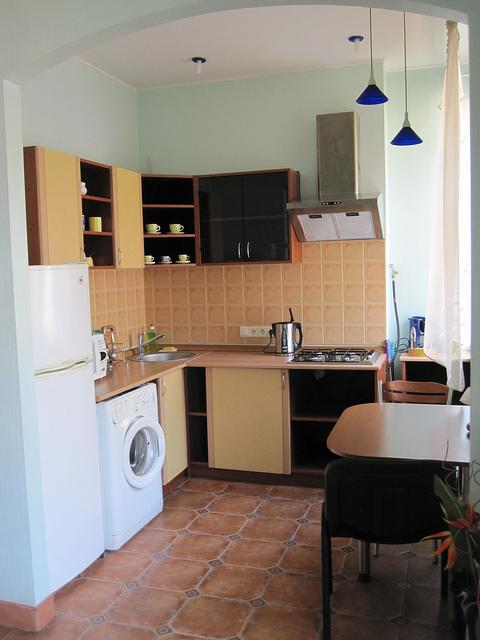Which appliance sits right next to the refrigerator?

Choices:
A) washing machine
B) oven
C) dishwasher
D) sink washing machine 